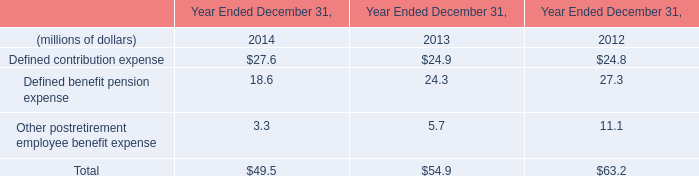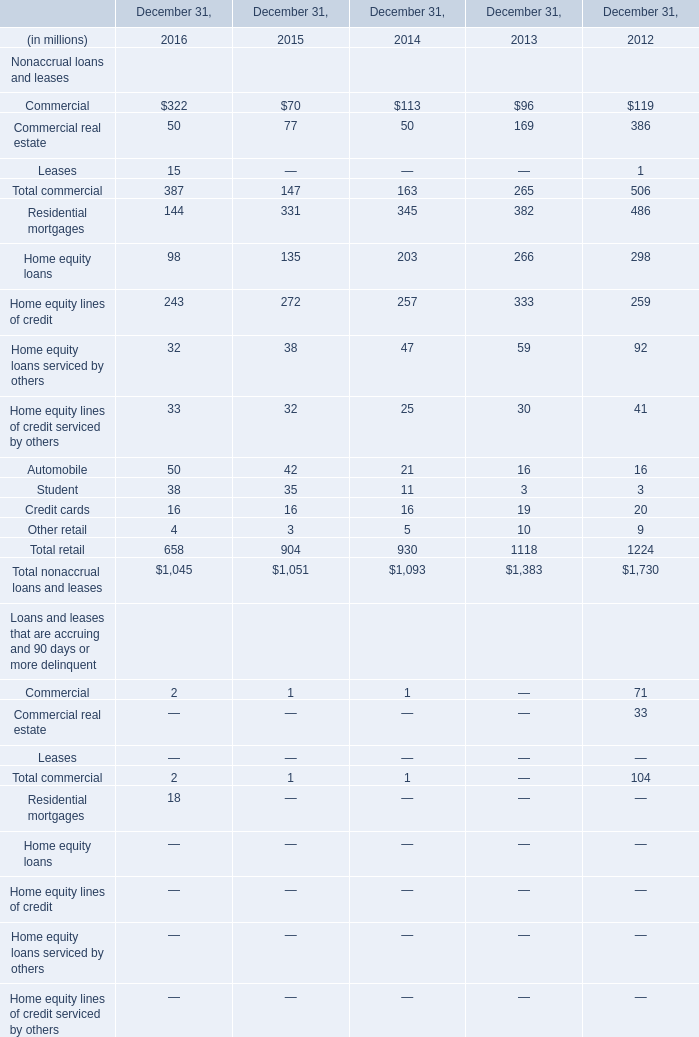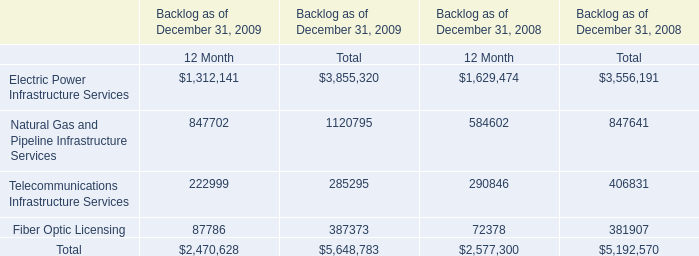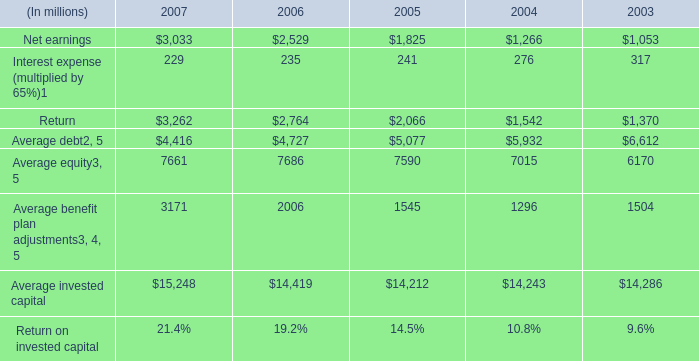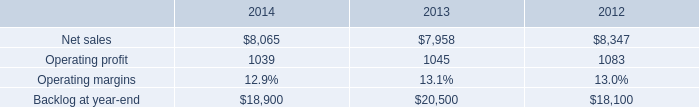what is the highest total amount of Commercial real estate? (in million) 
Answer: 322. 